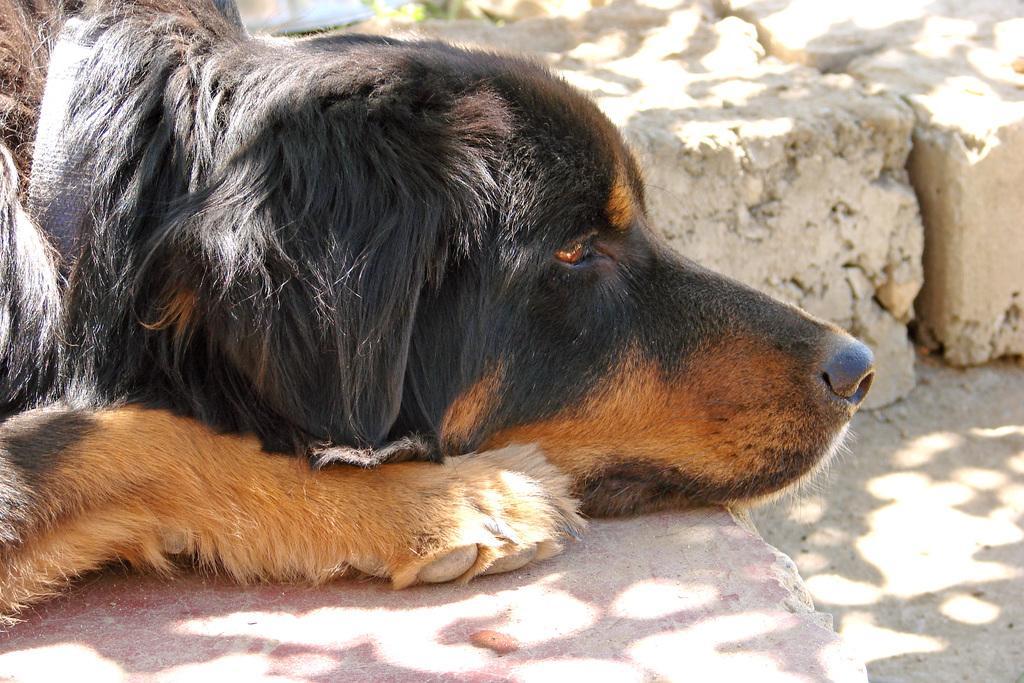Describe this image in one or two sentences. Here we can see a dog. Dog is facing towards the right side of the image.  